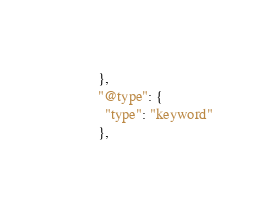Convert code to text. <code><loc_0><loc_0><loc_500><loc_500><_Bash_>        },
        "@type": {
          "type": "keyword"
        },</code> 